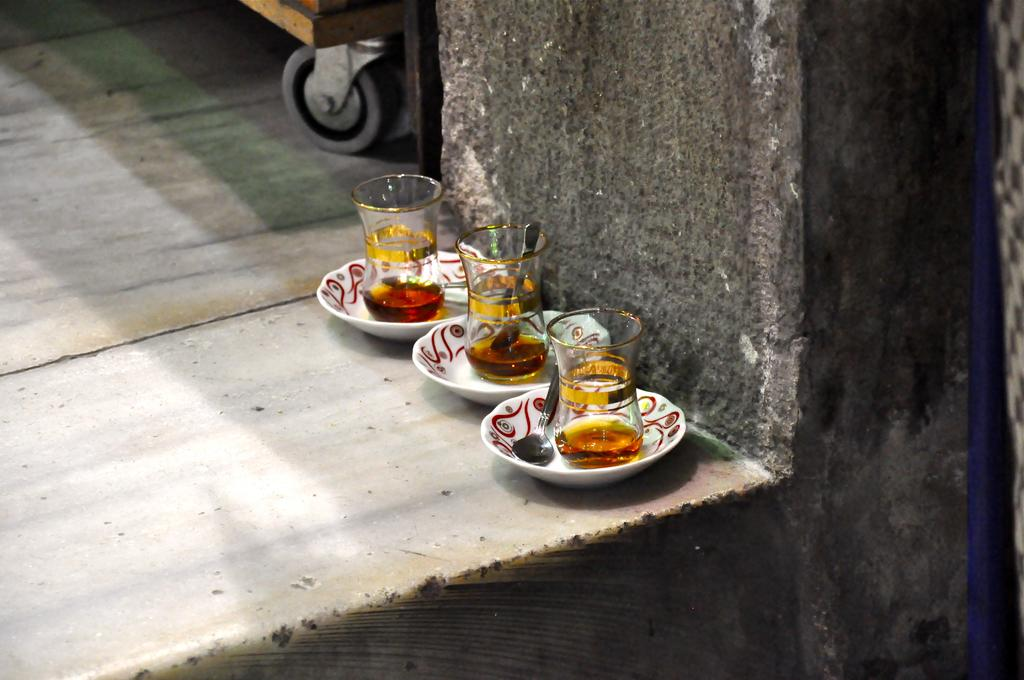What objects are on the floor in the image? There are bowls and glasses on the floor in the image. What can be seen in the background of the image? There is a vehicle and a wall in the background of the image. When was the image taken? The image was taken during the day. What type of instrument is being played by the rose in the image? There is no rose or instrument present in the image. 